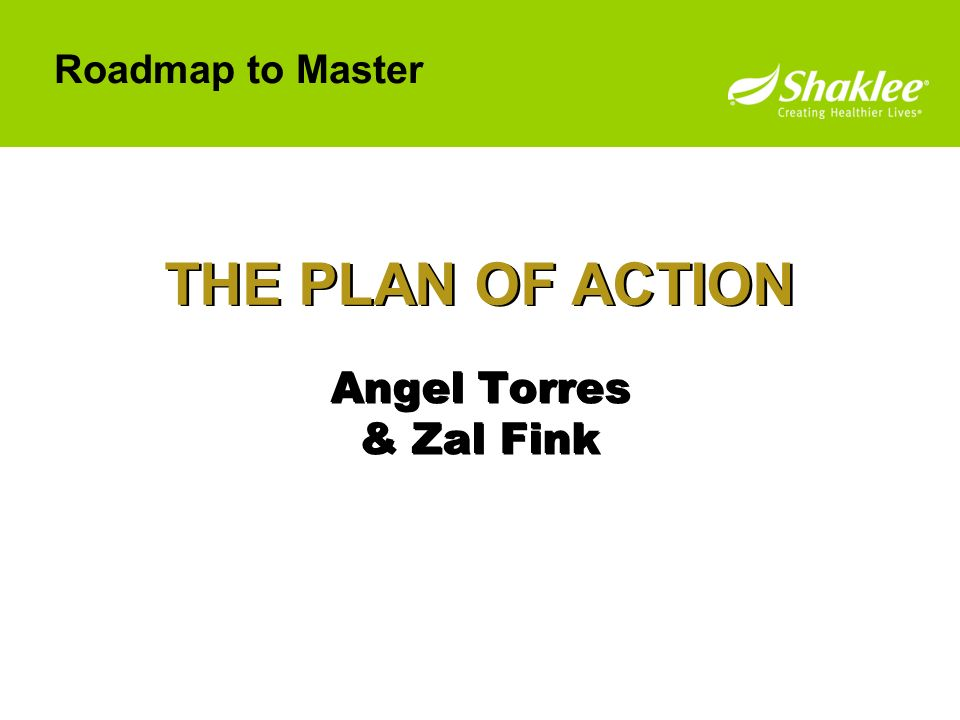Can you describe the theme and purpose of the presentation this slide belongs to? The slide seems to be a part of a presentation focused on strategic planning and development, possibly within a business or corporate environment. The title 'THE PLAN OF ACTION' and the phrase 'Roadmap to Master' suggest that the presentation might outline steps, strategies, or plans intended to achieve specific goals. It could be a motivational segment aimed at guiding employees or team members through a structured approach to mastering a particular skill set or achieving a significant milestone. The use of names suggests presenting or collaborative accountability, which often features in team-oriented business presentations. 